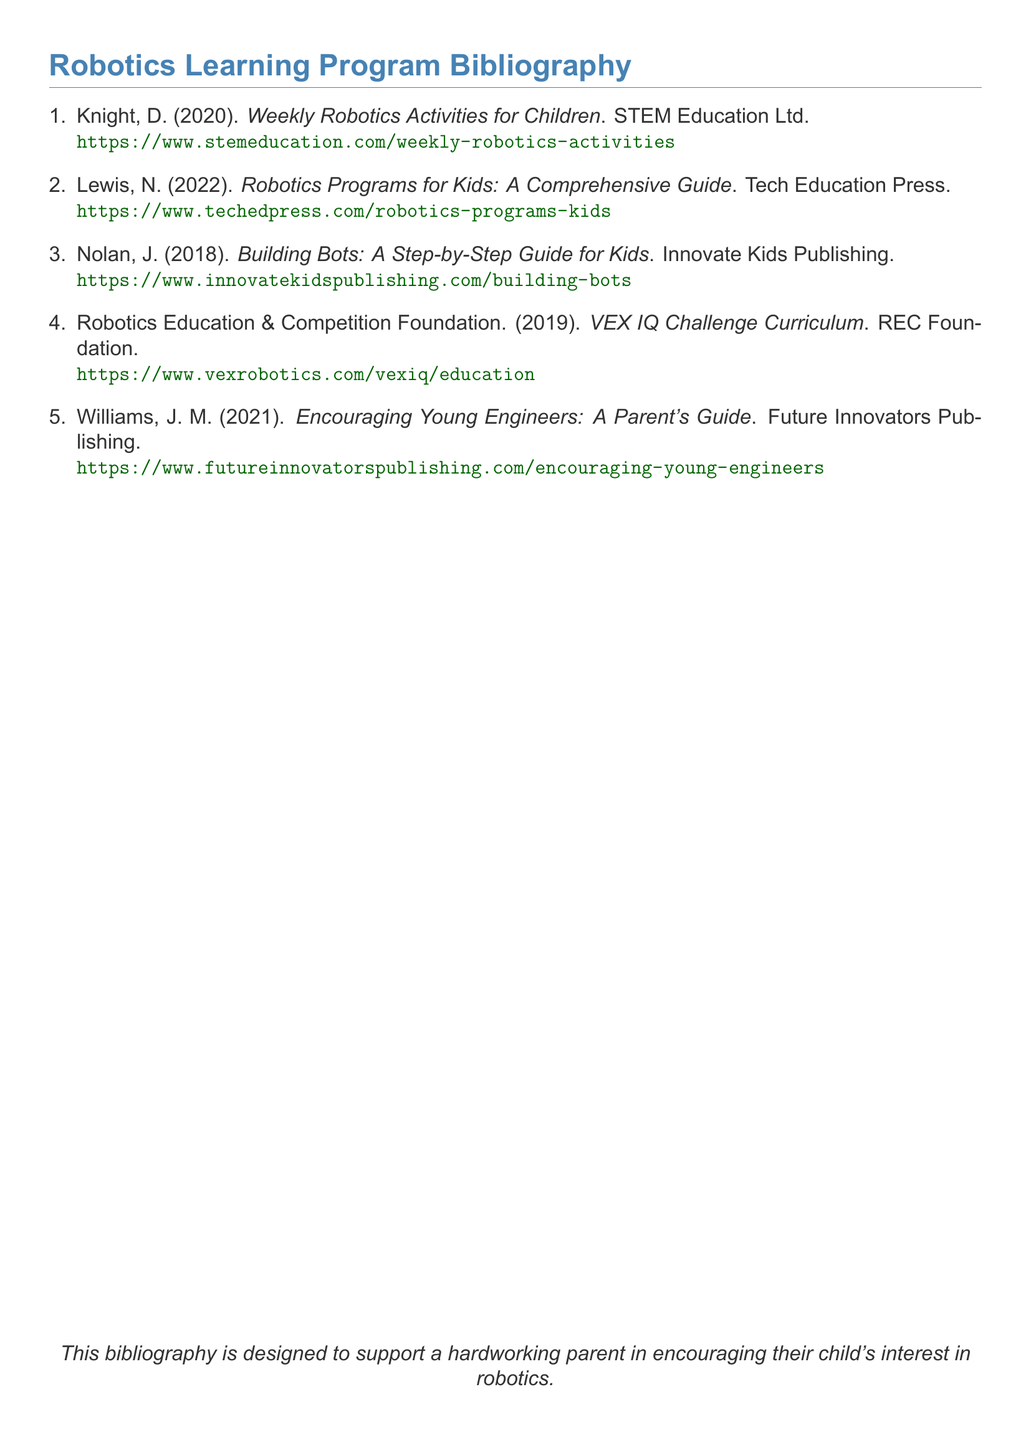What is the title of the first entry? The first entry in the bibliography is titled "Weekly Robotics Activities for Children".
Answer: Weekly Robotics Activities for Children Who is the author of the book published in 2022? The book published in 2022 is authored by N. Lewis.
Answer: N. Lewis What organization published the VEX IQ Challenge Curriculum? The VEX IQ Challenge Curriculum is published by the Robotics Education & Competition Foundation.
Answer: Robotics Education & Competition Foundation How many entries are in the bibliography? The bibliography lists a total of five entries.
Answer: 5 What is the publication year of "Building Bots: A Step-by-Step Guide for Kids"? "Building Bots: A Step-by-Step Guide for Kids" was published in 2018.
Answer: 2018 Which entry focuses on encouraging parents? The entry that focuses on encouraging parents is "Encouraging Young Engineers: A Parent's Guide".
Answer: Encouraging Young Engineers: A Parent's Guide What is the purpose of this bibliography as stated in the document? The purpose stated is to support a hardworking parent in encouraging their child's interest in robotics.
Answer: Support a hardworking parent in encouraging their child's interest in robotics 